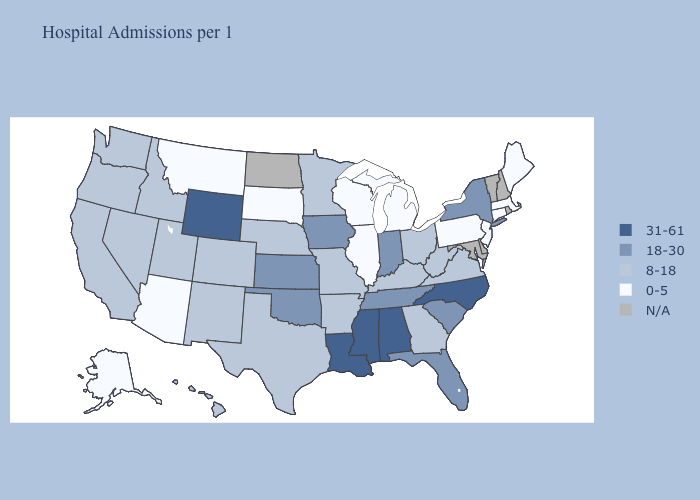What is the value of Wyoming?
Answer briefly. 31-61. Among the states that border Louisiana , does Arkansas have the highest value?
Concise answer only. No. What is the highest value in the West ?
Keep it brief. 31-61. What is the lowest value in states that border Michigan?
Quick response, please. 0-5. What is the value of Georgia?
Short answer required. 8-18. Name the states that have a value in the range 18-30?
Short answer required. Florida, Indiana, Iowa, Kansas, New York, Oklahoma, South Carolina, Tennessee. What is the lowest value in states that border North Dakota?
Give a very brief answer. 0-5. Does Pennsylvania have the lowest value in the USA?
Give a very brief answer. Yes. What is the highest value in the Northeast ?
Quick response, please. 18-30. Does the first symbol in the legend represent the smallest category?
Quick response, please. No. Among the states that border North Carolina , which have the lowest value?
Short answer required. Georgia, Virginia. Does the map have missing data?
Short answer required. Yes. Name the states that have a value in the range N/A?
Be succinct. Delaware, Maryland, New Hampshire, North Dakota, Rhode Island, Vermont. 